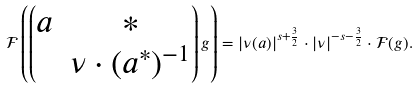Convert formula to latex. <formula><loc_0><loc_0><loc_500><loc_500>\mathcal { F } \left ( \begin{pmatrix} a & * \\ & \nu \cdot ( a ^ { * } ) ^ { - 1 } \end{pmatrix} g \right ) = | \nu ( a ) | ^ { s + \frac { 3 } { 2 } } \cdot | \nu | ^ { - s - \frac { 3 } { 2 } } \cdot \mathcal { F } ( g ) .</formula> 